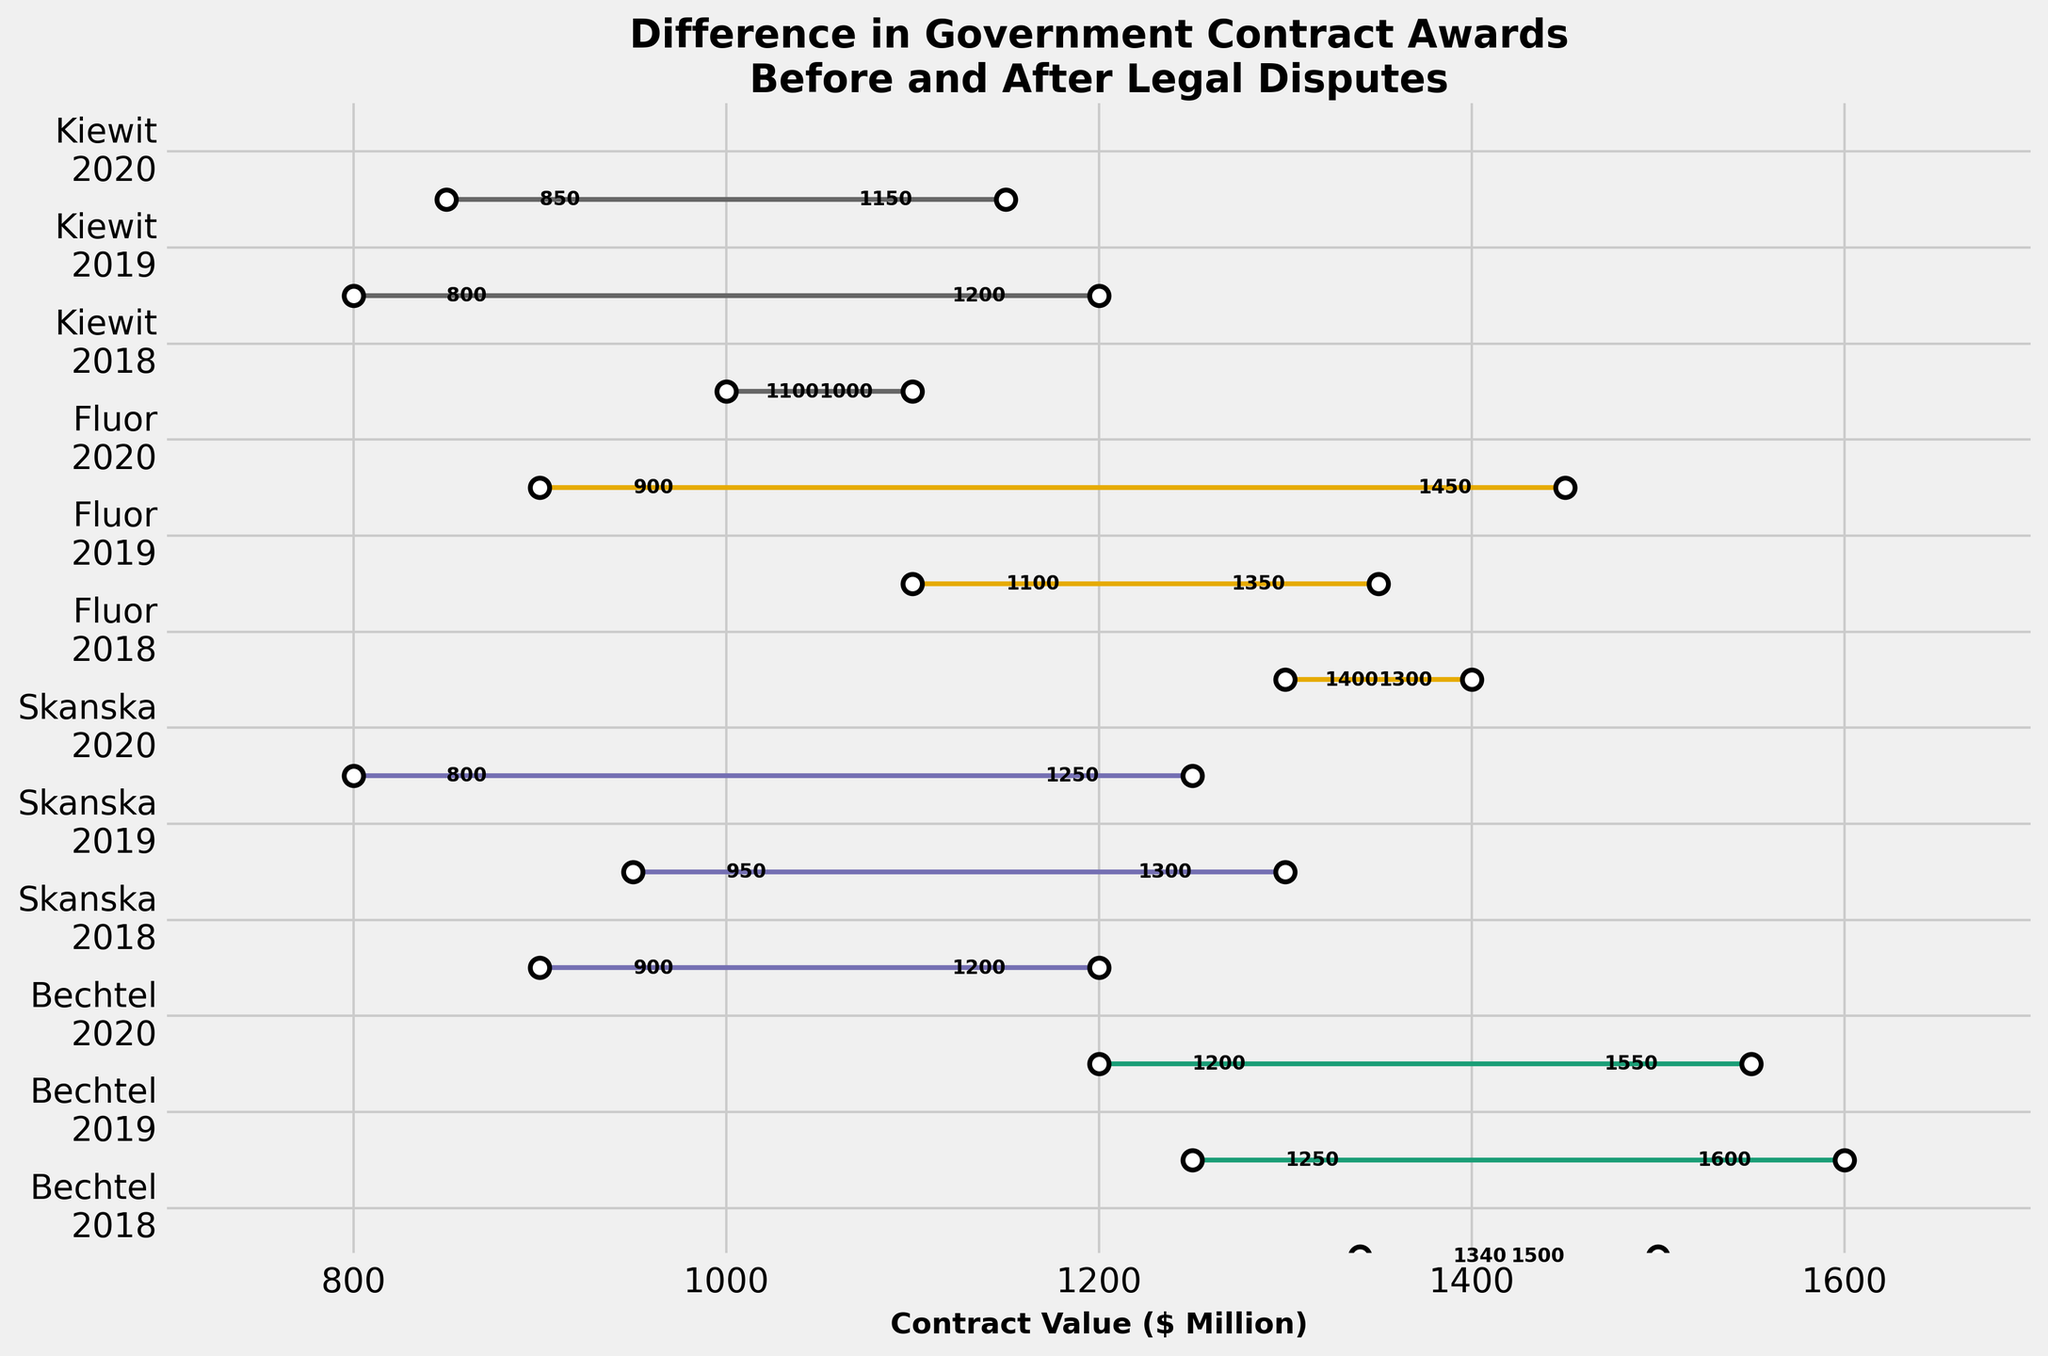What's the title of the plot? The title of the plot is written at the top, which usually gives a concise summary of what the plot is about.
Answer: Difference in Government Contract Awards Before and After Legal Disputes What is the x-axis label? The x-axis label is generally written below the horizontal axis of the plot to indicate what the axis represents.
Answer: Contract Value ($ Million) How much did Fluor's contracts decrease from 2019 to 2020? Look at the values of Fluor's contracts before and after the lawsuit in 2019 and 2020. Subtract the after value for 2020 from the after value for 2019.
Answer: 200 million Which company saw the largest decrease in contract value after legal disputes in 2020? Compare the drop in contract values (before and after) for all companies in 2020.
Answer: Fluor Between Bechtel and Skanska, which company had a larger decrease in contract value after legal disputes in 2018? Look at the contracts for Bechtel and Skanska in 2018 and compare the difference between before and after values for both companies.
Answer: Skanska What is the average contract value before the lawsuit across all companies in 2019? Sum the contract values before the lawsuit for all companies in 2019 and divide by the number of companies. The values are 1600, 1300, 1350, and 1200 (sum = 5450) divided by 4.
Answer: 1362.5 million In which year did Kiewit have the smallest difference in contract values before and after legal disputes? Compare the differences in Kiewit's contract values before and after disputes for each year and identify the smallest difference.
Answer: 2020 What was the total contract value for Bechtel before lawsuits across the given years? Add the contract values before the lawsuit for Bechtel in 2018, 2019, and 2020. The values are 1500, 1600, and 1550.
Answer: 4650 million Which company had a higher contract value after legal disputes in 2019: Fluor or Kiewit? Compare the contract values after the lawsuit for both Fluor and Kiewit in 2019.
Answer: Fluor How does the average decrease in contract value after lawsuits compare between Bechtel and Skanska in 2019? Calculate the average decrease for both companies: subtract the after value from the before value for both companies in 2019 and compare the averages. Bechtel: (1600 - 1250) = 350, Skanska: (1300 - 950) = 350.
Answer: They are the same (350 million each) 